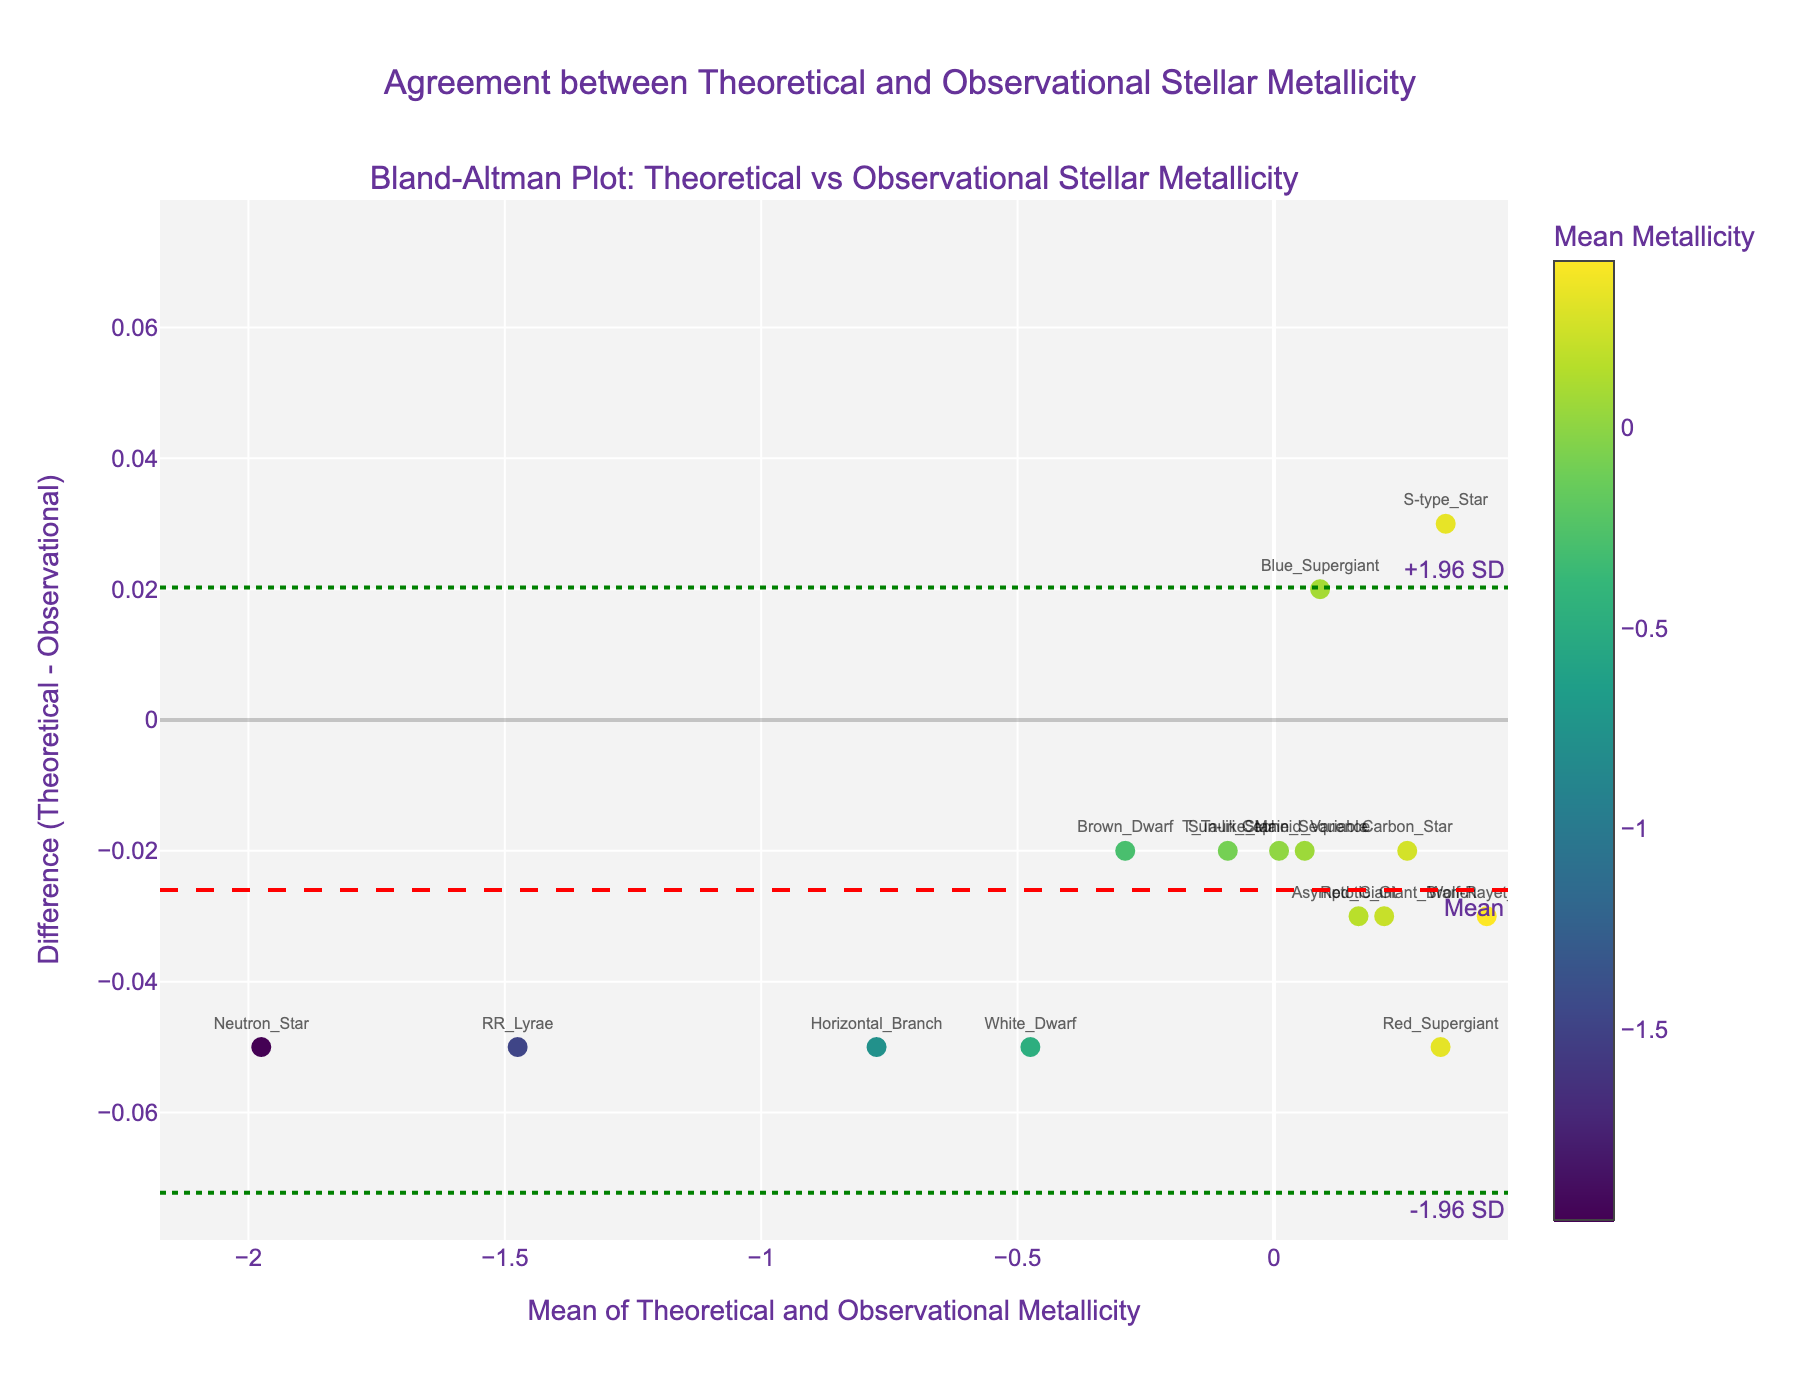What's the title of the plot? The plot title is positioned at the top center and reads "Agreement between Theoretical and Observational Stellar Metallicity".
Answer: Agreement between Theoretical and Observational Stellar Metallicity How many data points are represented in the plot? Each stellar type represents a data point in the scatter plot. By counting the number of unique stellar types (indicated by text annotations), we can determine there are 15 data points.
Answer: 15 Which stellar type has the largest difference between theoretical and observational metallicity? Observing the y-axis values (Difference), the largest difference is found at the data point labeled "Neutron_Star", which has the largest absolute value in the negative direction.
Answer: Neutron_Star What is the color scale based on? The color scale is based on the mean of theoretical and observational metallicity values, as indicated by the title of the color bar and the color of the data points.
Answer: Mean Metallicity What is the mean difference between theoretical and observational metallicity? The mean difference is indicated by the red dashed horizontal line on the plot. This line is annotated with "Mean" and positioned near y=0.03.
Answer: 0.03 What are the upper and lower limits of agreement? These limits are represented by green dotted horizontal lines on the plot, annotated with "+1.96 SD" and "-1.96 SD". The upper limit is around y=0.10 and the lower around y=-0.04.
Answer: 0.10, -0.04 Is there a general trend in the differences related to the mean of the metallicities? By examining the scatter plot, it appears that the differences do not show a clear trend as the mean metallicity values increase or decrease. The differences are relatively spread out irrespective of the mean values.
Answer: No clear trend Which stellar type lies closest to the mean difference line? The stellar type nearest to the red dashed line (mean difference) is "Cepheid_Variable", as it lies very close to y=0.03.
Answer: Cepheid_Variable Are there more data points above or below the mean difference line? By visually counting, there are 7 data points above the red dashed line (mean difference line) and 8 below.
Answer: Below 